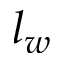<formula> <loc_0><loc_0><loc_500><loc_500>l _ { w }</formula> 